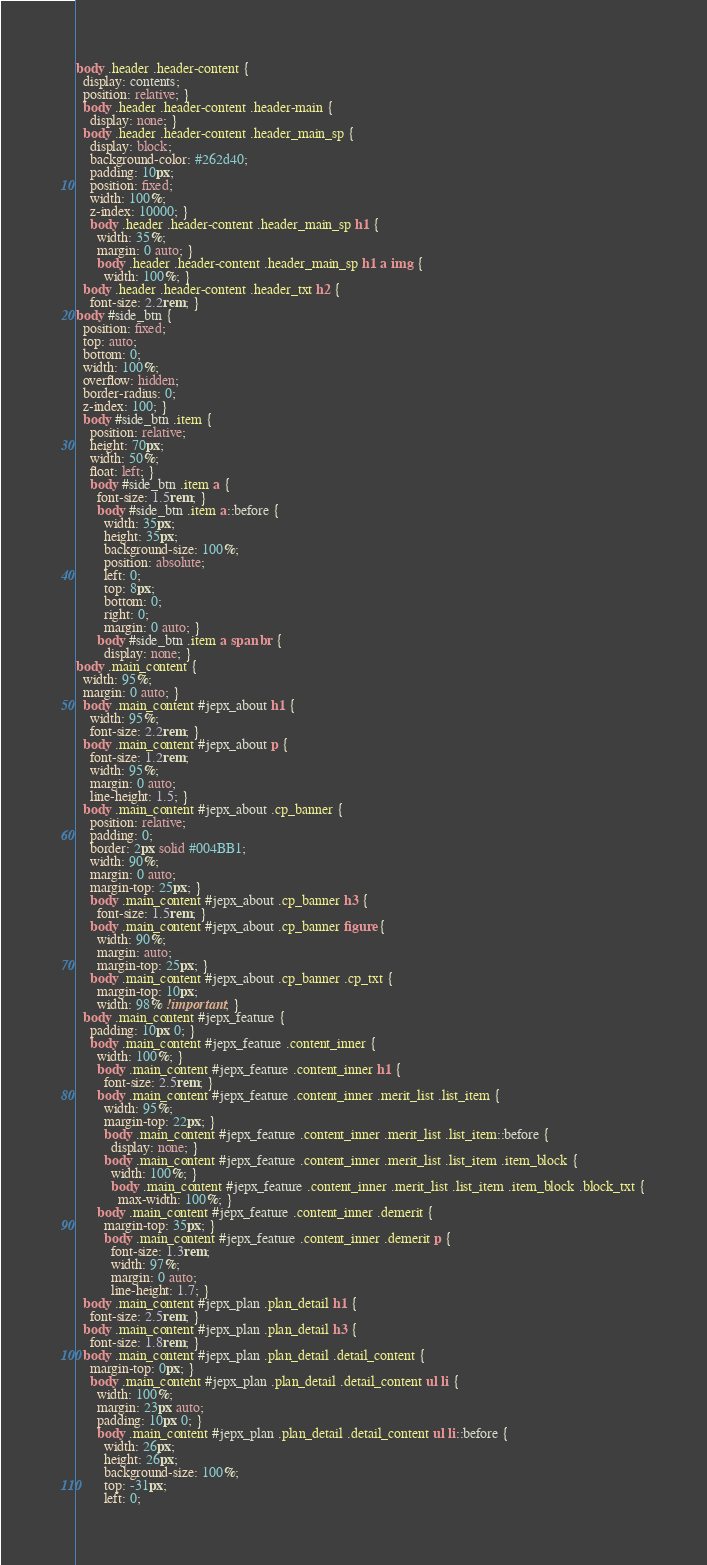<code> <loc_0><loc_0><loc_500><loc_500><_CSS_>body .header .header-content {
  display: contents;
  position: relative; }
  body .header .header-content .header-main {
    display: none; }
  body .header .header-content .header_main_sp {
    display: block;
    background-color: #262d40;
    padding: 10px;
    position: fixed;
    width: 100%;
    z-index: 10000; }
    body .header .header-content .header_main_sp h1 {
      width: 35%;
      margin: 0 auto; }
      body .header .header-content .header_main_sp h1 a img {
        width: 100%; }
  body .header .header-content .header_txt h2 {
    font-size: 2.2rem; }
body #side_btn {
  position: fixed;
  top: auto;
  bottom: 0;
  width: 100%;
  overflow: hidden;
  border-radius: 0;
  z-index: 100; }
  body #side_btn .item {
    position: relative;
    height: 70px;
    width: 50%;
    float: left; }
    body #side_btn .item a {
      font-size: 1.5rem; }
      body #side_btn .item a::before {
        width: 35px;
        height: 35px;
        background-size: 100%;
        position: absolute;
        left: 0;
        top: 8px;
        bottom: 0;
        right: 0;
        margin: 0 auto; }
      body #side_btn .item a span br {
        display: none; }
body .main_content {
  width: 95%;
  margin: 0 auto; }
  body .main_content #jepx_about h1 {
    width: 95%;
    font-size: 2.2rem; }
  body .main_content #jepx_about p {
    font-size: 1.2rem;
    width: 95%;
    margin: 0 auto;
    line-height: 1.5; }
  body .main_content #jepx_about .cp_banner {
    position: relative;
    padding: 0;
    border: 2px solid #004BB1;
    width: 90%;
    margin: 0 auto;
    margin-top: 25px; }
    body .main_content #jepx_about .cp_banner h3 {
      font-size: 1.5rem; }
    body .main_content #jepx_about .cp_banner figure {
      width: 90%;
      margin: auto;
      margin-top: 25px; }
    body .main_content #jepx_about .cp_banner .cp_txt {
      margin-top: 10px;
      width: 98% !important; }
  body .main_content #jepx_feature {
    padding: 10px 0; }
    body .main_content #jepx_feature .content_inner {
      width: 100%; }
      body .main_content #jepx_feature .content_inner h1 {
        font-size: 2.5rem; }
      body .main_content #jepx_feature .content_inner .merit_list .list_item {
        width: 95%;
        margin-top: 22px; }
        body .main_content #jepx_feature .content_inner .merit_list .list_item::before {
          display: none; }
        body .main_content #jepx_feature .content_inner .merit_list .list_item .item_block {
          width: 100%; }
          body .main_content #jepx_feature .content_inner .merit_list .list_item .item_block .block_txt {
            max-width: 100%; }
      body .main_content #jepx_feature .content_inner .demerit {
        margin-top: 35px; }
        body .main_content #jepx_feature .content_inner .demerit p {
          font-size: 1.3rem;
          width: 97%;
          margin: 0 auto;
          line-height: 1.7; }
  body .main_content #jepx_plan .plan_detail h1 {
    font-size: 2.5rem; }
  body .main_content #jepx_plan .plan_detail h3 {
    font-size: 1.8rem; }
  body .main_content #jepx_plan .plan_detail .detail_content {
    margin-top: 0px; }
    body .main_content #jepx_plan .plan_detail .detail_content ul li {
      width: 100%;
      margin: 23px auto;
      padding: 10px 0; }
      body .main_content #jepx_plan .plan_detail .detail_content ul li::before {
        width: 26px;
        height: 26px;
        background-size: 100%;
        top: -31px;
        left: 0;</code> 